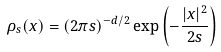<formula> <loc_0><loc_0><loc_500><loc_500>\rho _ { s } ( x ) = ( 2 \pi s ) ^ { - d / 2 } \exp \left ( - \frac { | x | ^ { 2 } } { 2 s } \right )</formula> 